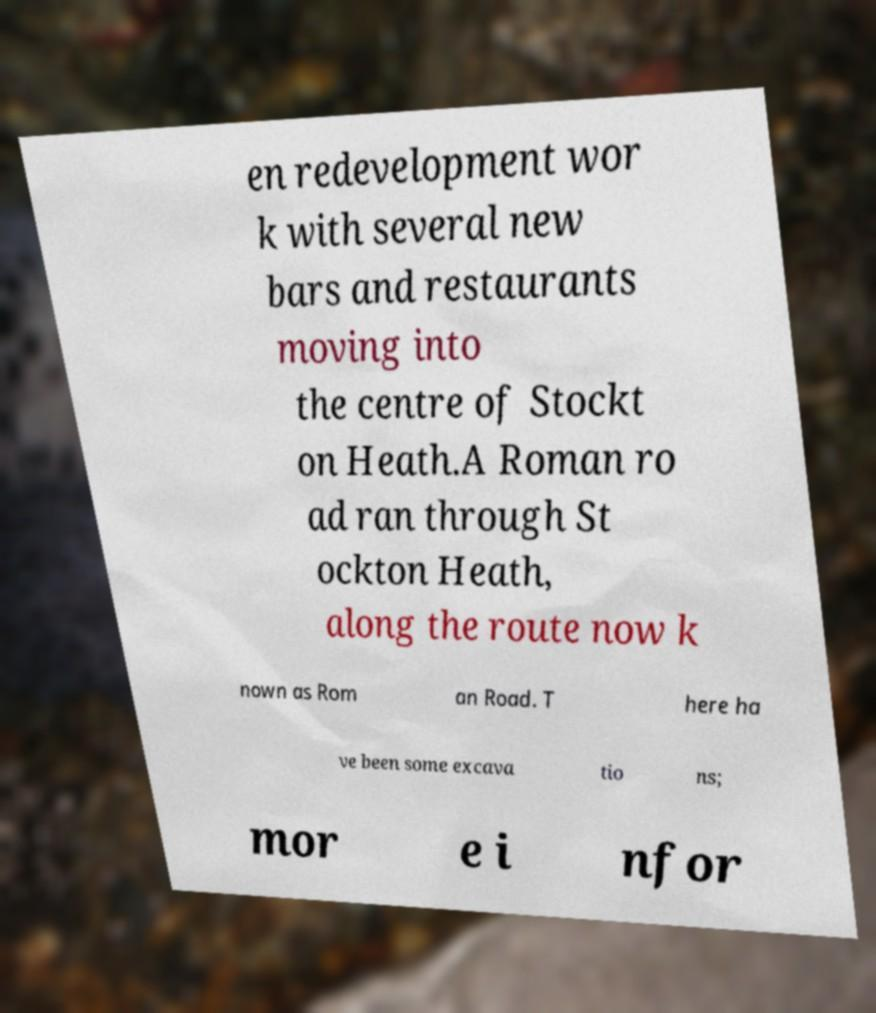Could you assist in decoding the text presented in this image and type it out clearly? en redevelopment wor k with several new bars and restaurants moving into the centre of Stockt on Heath.A Roman ro ad ran through St ockton Heath, along the route now k nown as Rom an Road. T here ha ve been some excava tio ns; mor e i nfor 